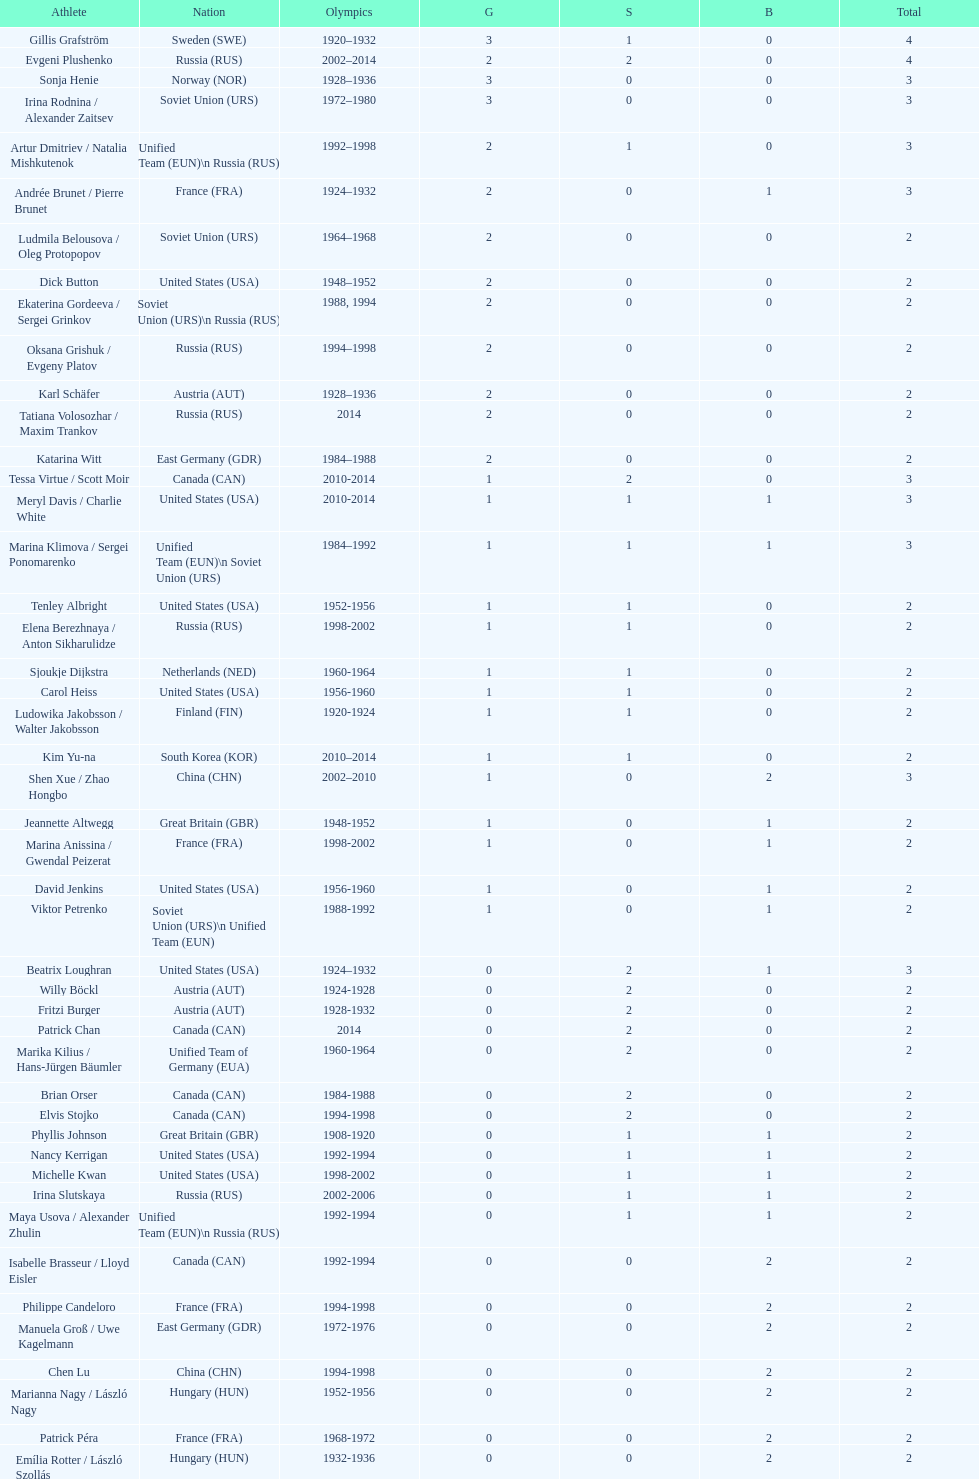How many silver medals did evgeni plushenko get? 2. 